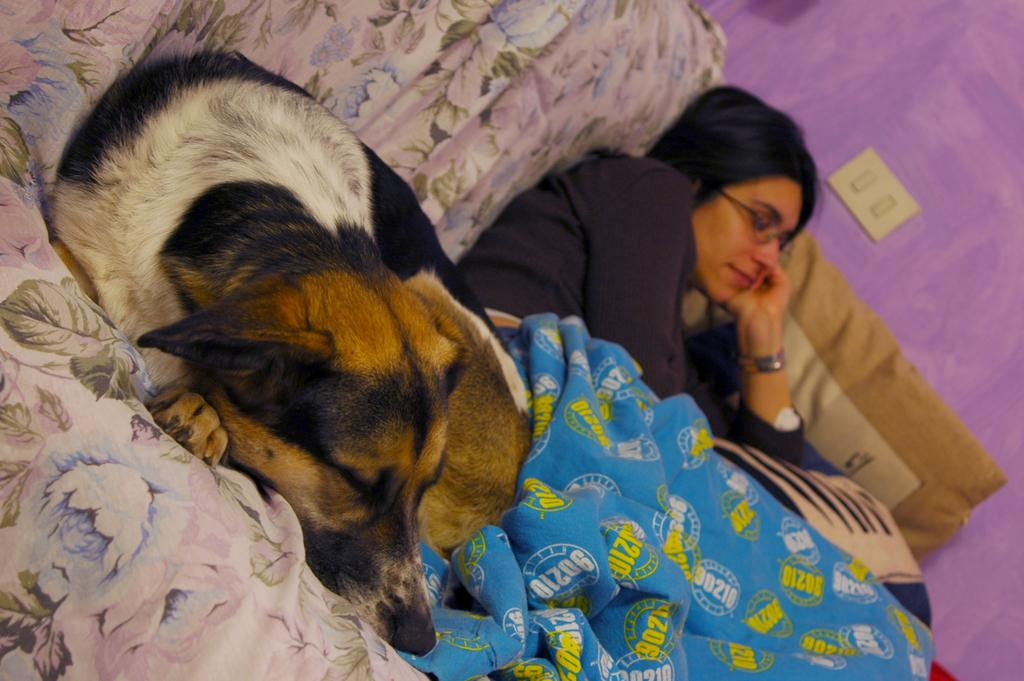Who is present in the image? There is a lady person in the image. What is the lady person doing? The lady person is sleeping. Is there any other living being in the image? Yes, there is a dog in the image. What is the dog doing? The dog is sleeping. Where are the lady person and the dog located? Both the lady person and the dog are on a couch. What type of ring can be seen on the lady person's finger in the image? There is no ring visible on the lady person's finger in the image. What kind of root is growing near the couch in the image? There is no root present in the image; it features a lady person and a dog sleeping on a couch. 